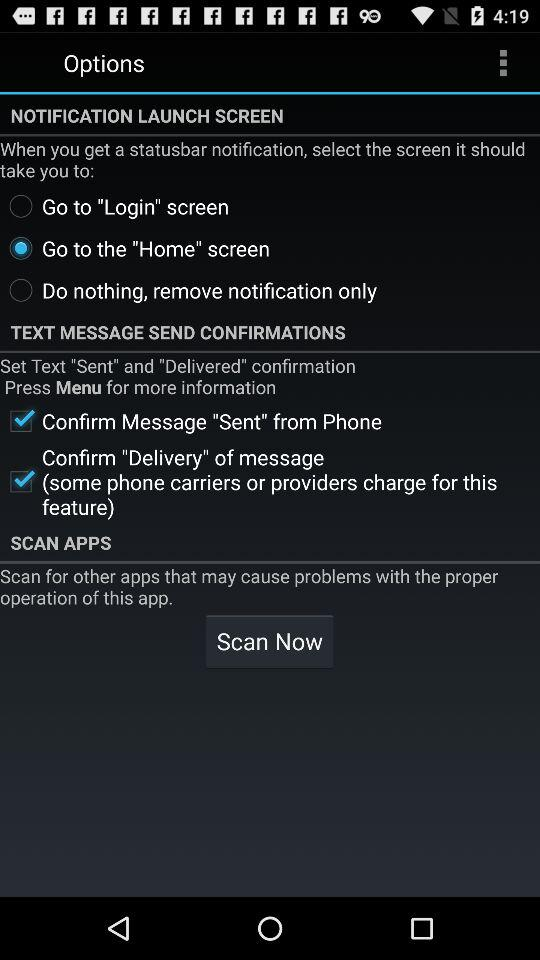For messages, which alerts are selected?
When the provided information is insufficient, respond with <no answer>. <no answer> 